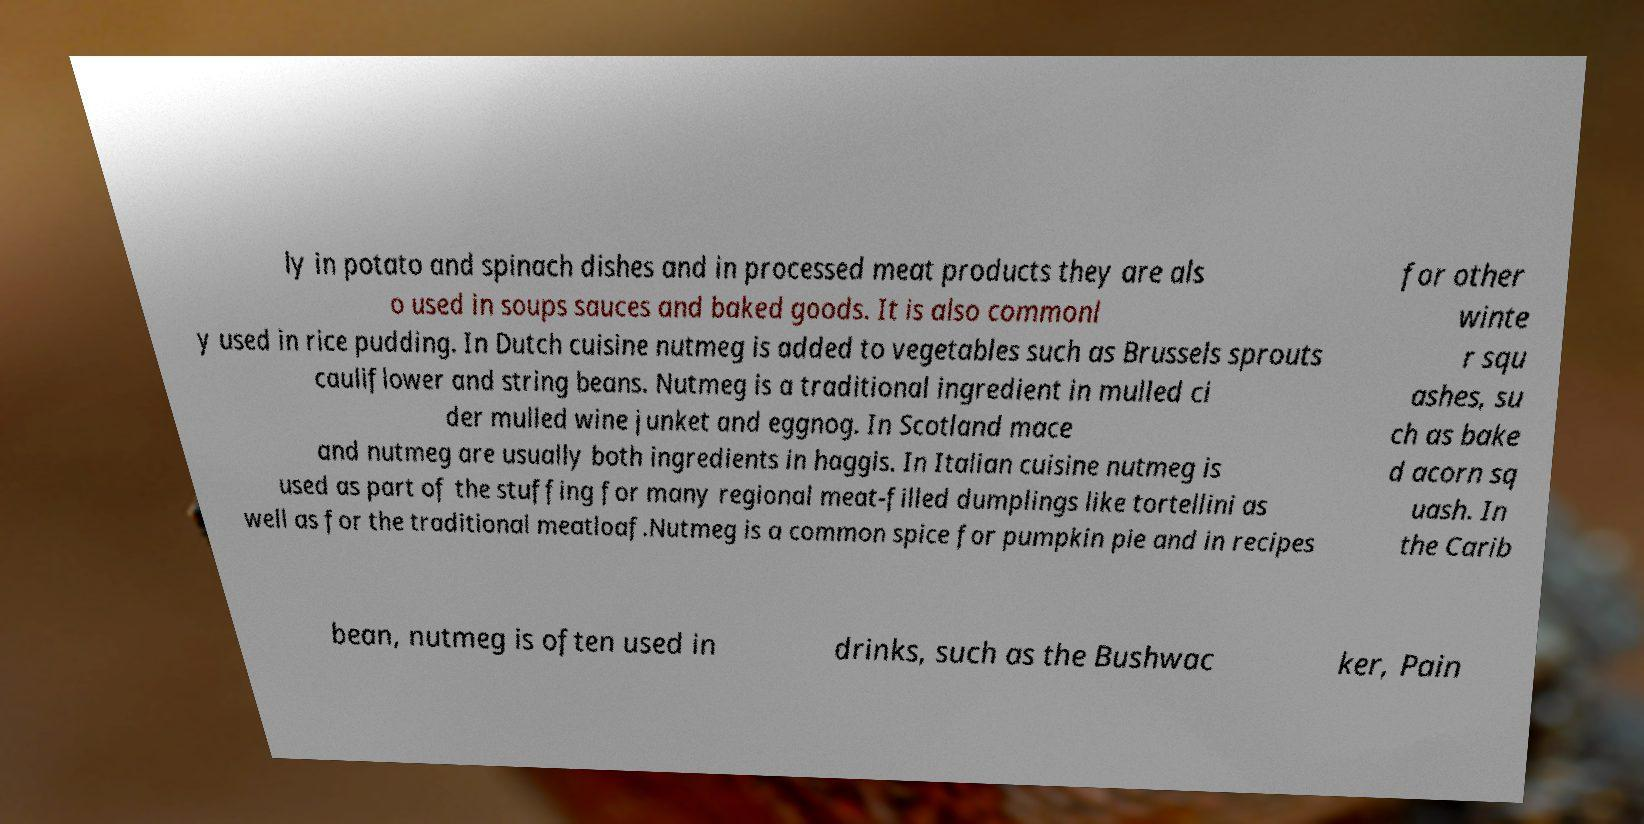Can you read and provide the text displayed in the image?This photo seems to have some interesting text. Can you extract and type it out for me? ly in potato and spinach dishes and in processed meat products they are als o used in soups sauces and baked goods. It is also commonl y used in rice pudding. In Dutch cuisine nutmeg is added to vegetables such as Brussels sprouts cauliflower and string beans. Nutmeg is a traditional ingredient in mulled ci der mulled wine junket and eggnog. In Scotland mace and nutmeg are usually both ingredients in haggis. In Italian cuisine nutmeg is used as part of the stuffing for many regional meat-filled dumplings like tortellini as well as for the traditional meatloaf.Nutmeg is a common spice for pumpkin pie and in recipes for other winte r squ ashes, su ch as bake d acorn sq uash. In the Carib bean, nutmeg is often used in drinks, such as the Bushwac ker, Pain 